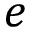Convert formula to latex. <formula><loc_0><loc_0><loc_500><loc_500>e</formula> 